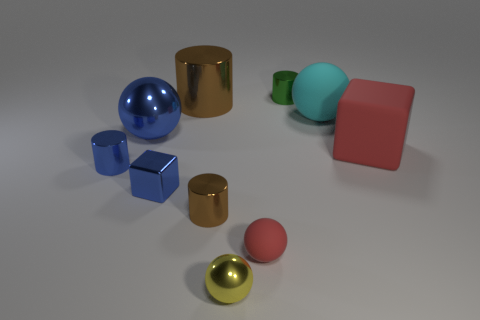Subtract all balls. How many objects are left? 6 Add 2 red things. How many red things exist? 4 Subtract all cyan balls. How many balls are left? 3 Subtract all large brown metallic cylinders. How many cylinders are left? 3 Subtract 0 cyan cylinders. How many objects are left? 10 Subtract 2 spheres. How many spheres are left? 2 Subtract all gray cylinders. Subtract all gray cubes. How many cylinders are left? 4 Subtract all red cubes. How many yellow cylinders are left? 0 Subtract all red metal things. Subtract all metallic cylinders. How many objects are left? 6 Add 4 blue balls. How many blue balls are left? 5 